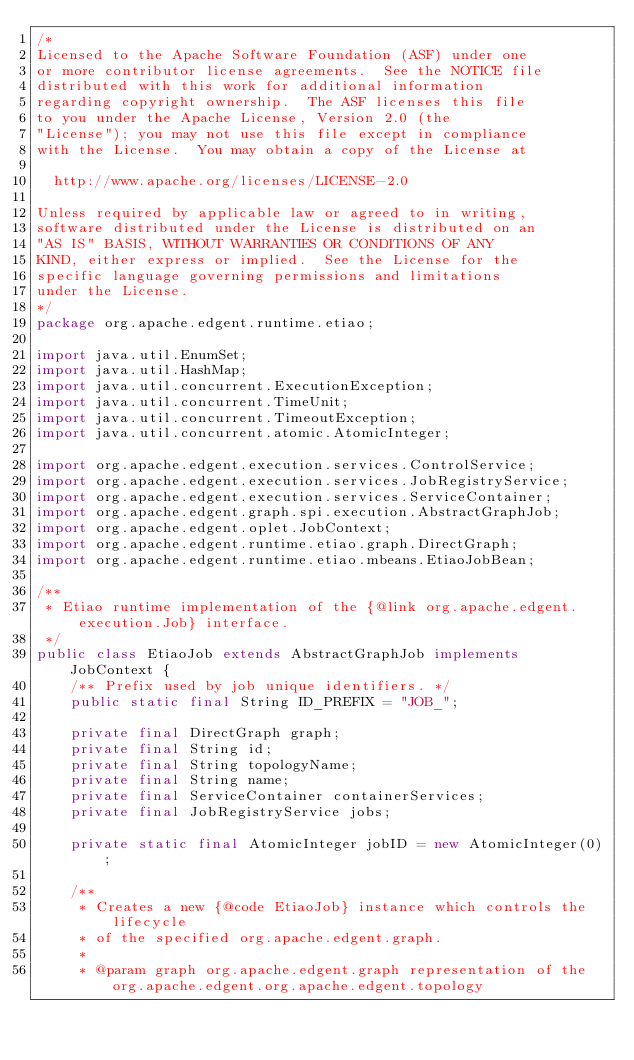<code> <loc_0><loc_0><loc_500><loc_500><_Java_>/*
Licensed to the Apache Software Foundation (ASF) under one
or more contributor license agreements.  See the NOTICE file
distributed with this work for additional information
regarding copyright ownership.  The ASF licenses this file
to you under the Apache License, Version 2.0 (the
"License"); you may not use this file except in compliance
with the License.  You may obtain a copy of the License at

  http://www.apache.org/licenses/LICENSE-2.0

Unless required by applicable law or agreed to in writing,
software distributed under the License is distributed on an
"AS IS" BASIS, WITHOUT WARRANTIES OR CONDITIONS OF ANY
KIND, either express or implied.  See the License for the
specific language governing permissions and limitations
under the License.
*/
package org.apache.edgent.runtime.etiao;

import java.util.EnumSet;
import java.util.HashMap;
import java.util.concurrent.ExecutionException;
import java.util.concurrent.TimeUnit;
import java.util.concurrent.TimeoutException;
import java.util.concurrent.atomic.AtomicInteger;

import org.apache.edgent.execution.services.ControlService;
import org.apache.edgent.execution.services.JobRegistryService;
import org.apache.edgent.execution.services.ServiceContainer;
import org.apache.edgent.graph.spi.execution.AbstractGraphJob;
import org.apache.edgent.oplet.JobContext;
import org.apache.edgent.runtime.etiao.graph.DirectGraph;
import org.apache.edgent.runtime.etiao.mbeans.EtiaoJobBean;

/**
 * Etiao runtime implementation of the {@link org.apache.edgent.execution.Job} interface.
 */
public class EtiaoJob extends AbstractGraphJob implements JobContext {
    /** Prefix used by job unique identifiers. */
    public static final String ID_PREFIX = "JOB_";
    
    private final DirectGraph graph;
    private final String id;
    private final String topologyName;
    private final String name;
    private final ServiceContainer containerServices;
    private final JobRegistryService jobs;

    private static final AtomicInteger jobID = new AtomicInteger(0);

    /**
     * Creates a new {@code EtiaoJob} instance which controls the lifecycle 
     * of the specified org.apache.edgent.graph.
     * 
     * @param graph org.apache.edgent.graph representation of the org.apache.edgent.org.apache.edgent.topology</code> 